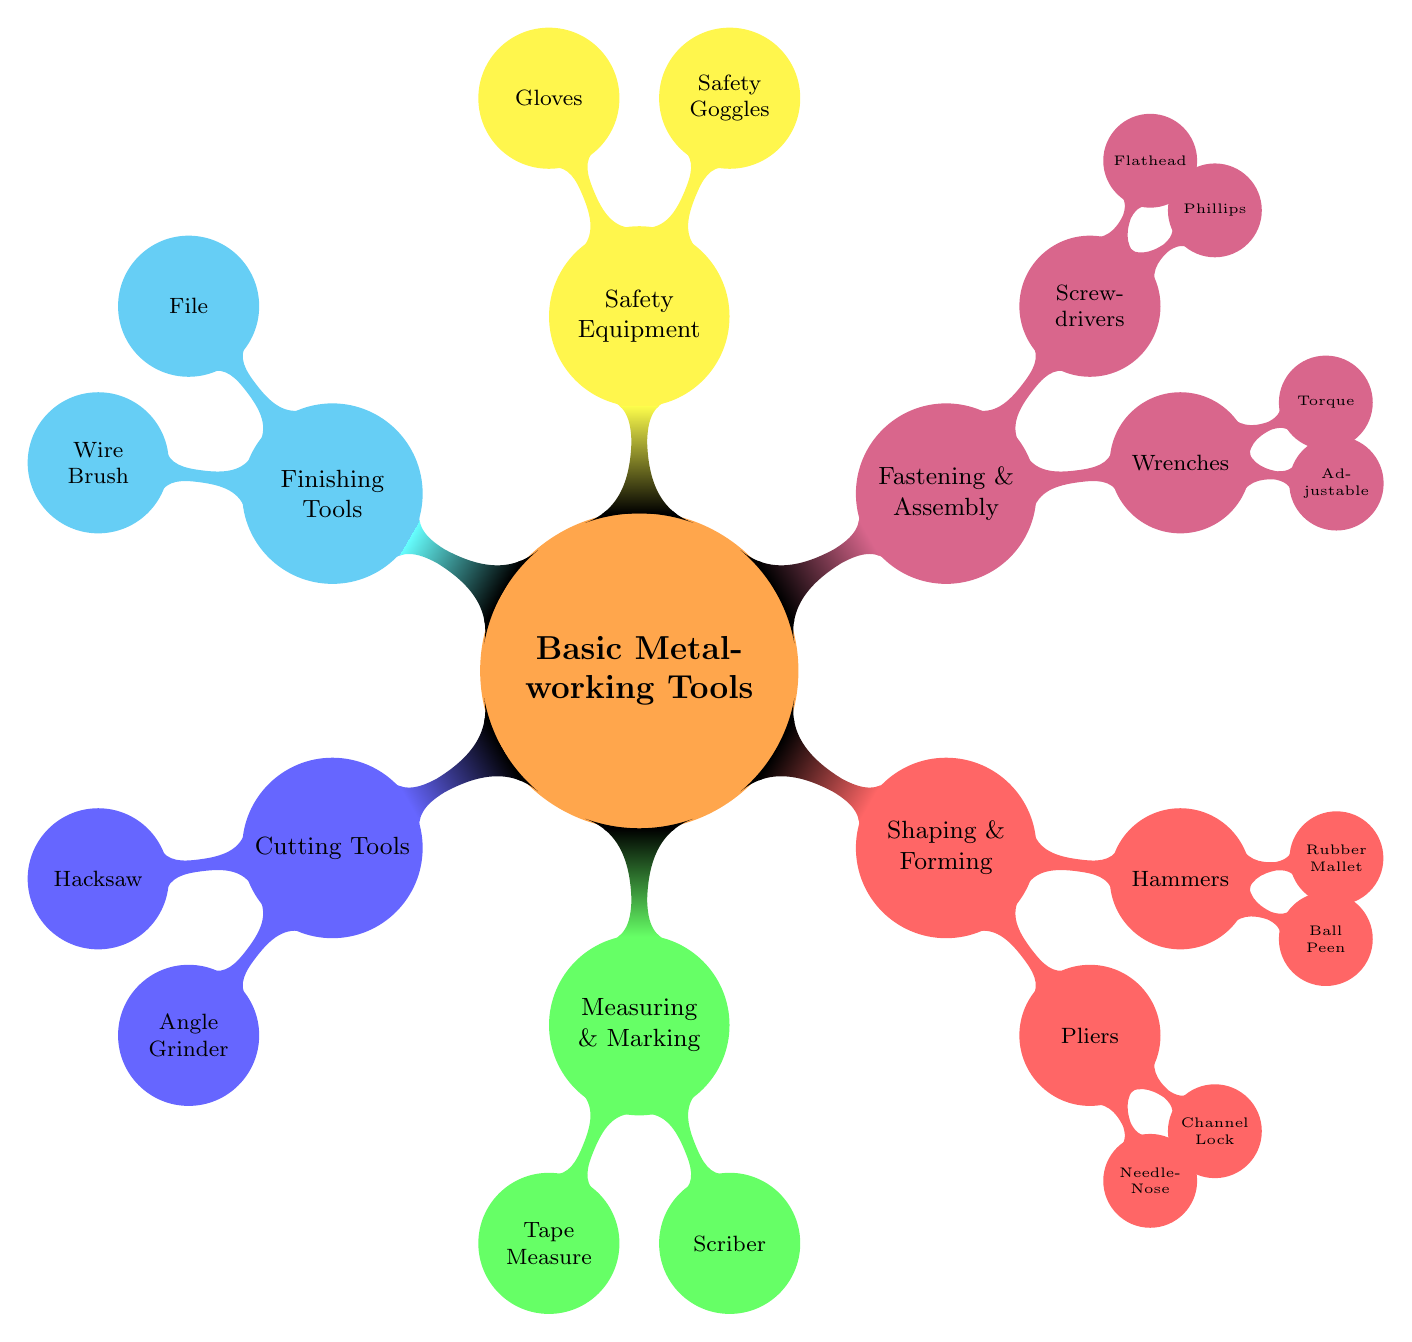What is the color of the "Cutting Tools" node? The "Cutting Tools" node is colored blue with a shade of blue 60, as indicated in the color coding presented in the diagram.
Answer: blue!60 How many tools are listed under "Shaping & Forming"? Under the "Shaping & Forming" branch, there are two types of tools (Pliers and Hammers), and each of those has two tools (Needle-Nose and Channel Lock for Pliers; Ball Peen and Rubber Mallet for Hammers), totaling four tools.
Answer: four Which tool is used for precise measurement? The tool specifically mentioned for taking precise measurements is the "Tape Measure," found under the "Measuring & Marking" section.
Answer: Tape Measure What is the function of the "Safety Goggles"? The "Safety Goggles" are meant to protect the eyes from metal shards and debris, which is explicitly stated in the description of the safety equipment.
Answer: Protects eyes from metal shards and debris Which tool is categorized under both "Fastening & Assembly" and is adjustable? The tool that is adjustable and falls under the "Fastening & Assembly" category is the "Adjustable Wrench," as identified in the respective section of the mind map.
Answer: Adjustable Wrench How many total categories of tools are in the diagram? The diagram has six distinct categories: Cutting Tools, Measuring & Marking, Shaping & Forming, Fastening & Assembly, Safety Equipment, and Finishing Tools, amounting to a total of six categories.
Answer: six Which tool is ideal for cleaning rust from metal surfaces? The tool used for cleaning rust and corrosion from metal surfaces is the "Wire Brush," located under the "Finishing Tools" category.
Answer: Wire Brush What two types of pliers are mentioned? The two types of pliers specified in the diagram are "Needle-Nose Pliers" and "Channel Lock Pliers," found within the "Pliers" section under "Shaping & Forming."
Answer: Needle-Nose Pliers and Channel Lock Pliers 